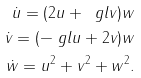Convert formula to latex. <formula><loc_0><loc_0><loc_500><loc_500>\dot { u } = ( 2 u + \ g l v ) w \\ \dot { v } = ( - \ g l u + 2 v ) w \\ \dot { w } = u ^ { 2 } + v ^ { 2 } + w ^ { 2 } .</formula> 